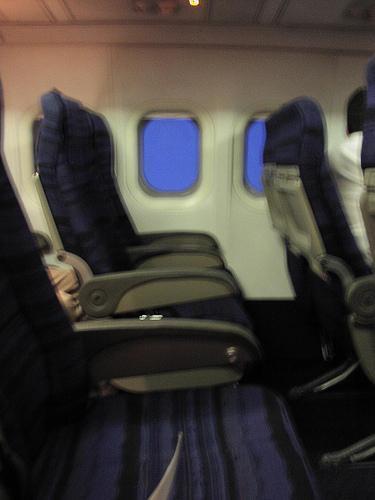How many windows are there?
Give a very brief answer. 2. 